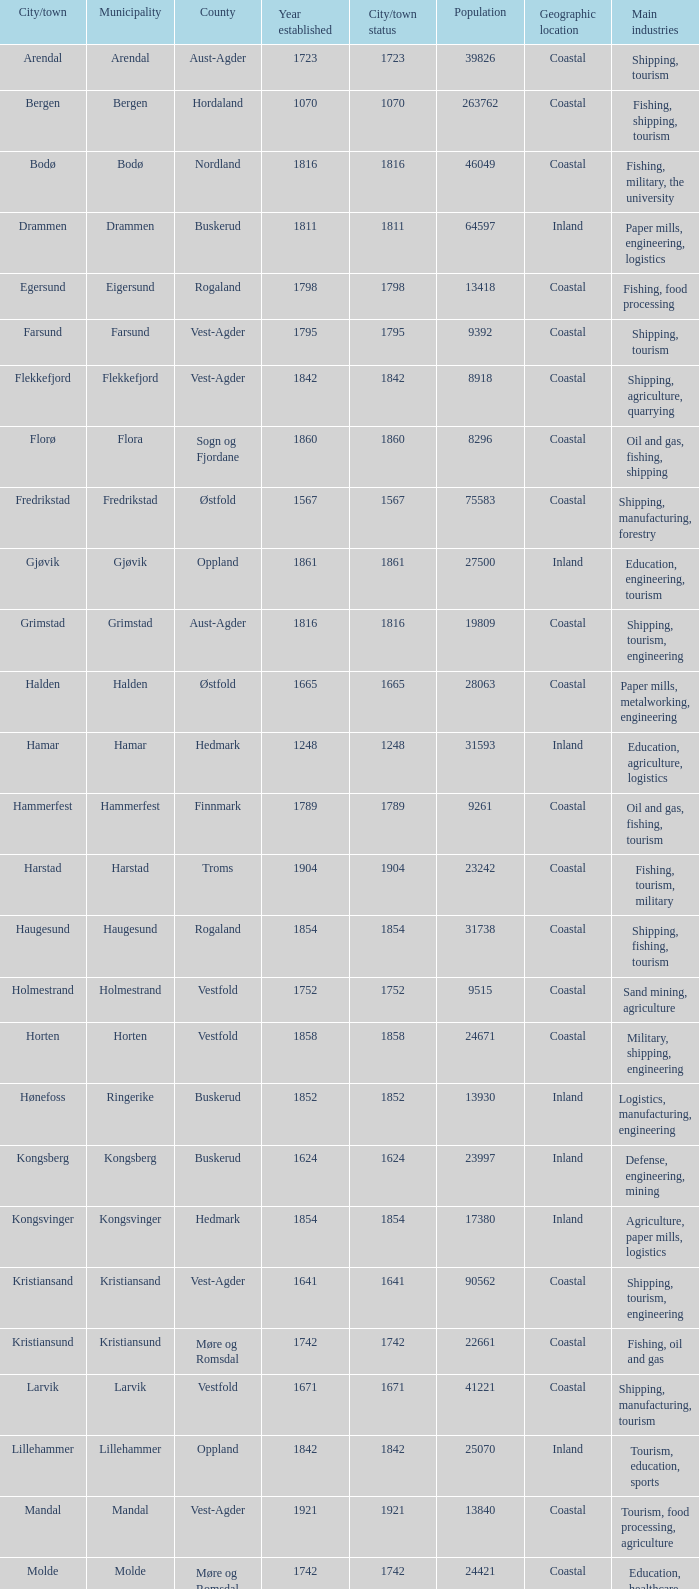In which county is the city/town of Halden located? Østfold. 